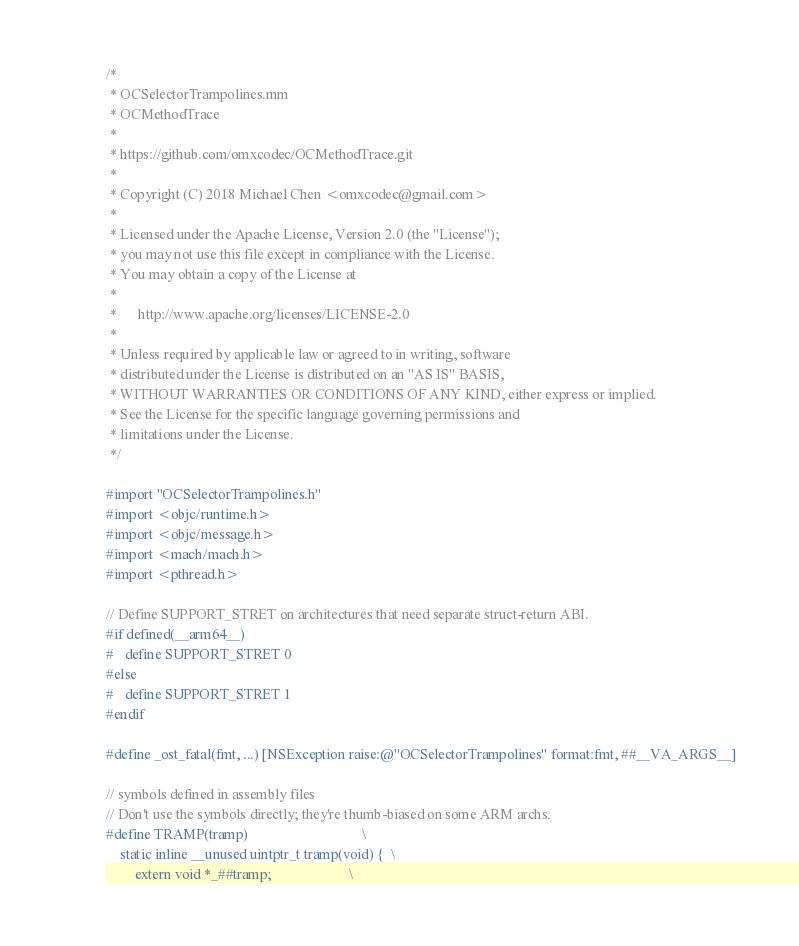Convert code to text. <code><loc_0><loc_0><loc_500><loc_500><_ObjectiveC_>/*
 * OCSelectorTrampolines.mm
 * OCMethodTrace
 *
 * https://github.com/omxcodec/OCMethodTrace.git
 *
 * Copyright (C) 2018 Michael Chen <omxcodec@gmail.com>
 *
 * Licensed under the Apache License, Version 2.0 (the "License");
 * you may not use this file except in compliance with the License.
 * You may obtain a copy of the License at
 *
 *      http://www.apache.org/licenses/LICENSE-2.0
 *
 * Unless required by applicable law or agreed to in writing, software
 * distributed under the License is distributed on an "AS IS" BASIS,
 * WITHOUT WARRANTIES OR CONDITIONS OF ANY KIND, either express or implied.
 * See the License for the specific language governing permissions and
 * limitations under the License.
 */

#import "OCSelectorTrampolines.h"
#import <objc/runtime.h>
#import <objc/message.h>
#import <mach/mach.h>
#import <pthread.h>

// Define SUPPORT_STRET on architectures that need separate struct-return ABI.
#if defined(__arm64__)
#   define SUPPORT_STRET 0
#else
#   define SUPPORT_STRET 1
#endif

#define _ost_fatal(fmt, ...) [NSException raise:@"OCSelectorTrampolines" format:fmt, ##__VA_ARGS__]

// symbols defined in assembly files
// Don't use the symbols directly; they're thumb-biased on some ARM archs.
#define TRAMP(tramp)                                \
    static inline __unused uintptr_t tramp(void) {  \
        extern void *_##tramp;                      \</code> 